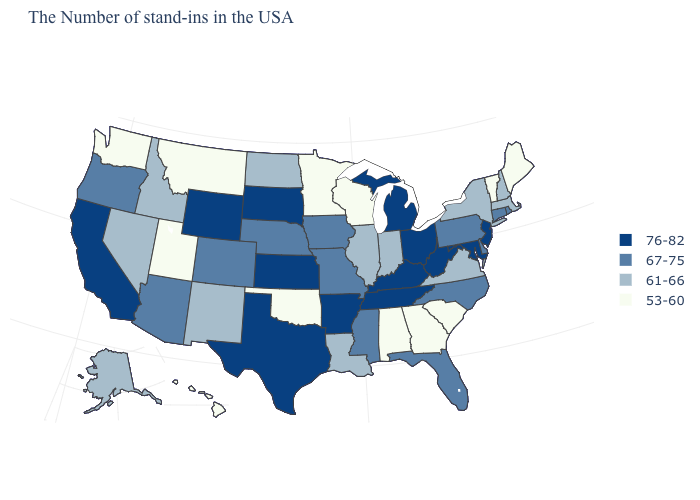Does Maine have the same value as Alabama?
Answer briefly. Yes. What is the value of Ohio?
Quick response, please. 76-82. Does Georgia have the same value as Oklahoma?
Write a very short answer. Yes. Which states hav the highest value in the Northeast?
Short answer required. New Jersey. Name the states that have a value in the range 61-66?
Be succinct. Massachusetts, New Hampshire, New York, Virginia, Indiana, Illinois, Louisiana, North Dakota, New Mexico, Idaho, Nevada, Alaska. What is the value of New Mexico?
Short answer required. 61-66. Name the states that have a value in the range 61-66?
Keep it brief. Massachusetts, New Hampshire, New York, Virginia, Indiana, Illinois, Louisiana, North Dakota, New Mexico, Idaho, Nevada, Alaska. What is the highest value in the West ?
Be succinct. 76-82. Which states have the lowest value in the West?
Concise answer only. Utah, Montana, Washington, Hawaii. Does the first symbol in the legend represent the smallest category?
Be succinct. No. Among the states that border New Hampshire , does Massachusetts have the lowest value?
Be succinct. No. Which states have the lowest value in the USA?
Short answer required. Maine, Vermont, South Carolina, Georgia, Alabama, Wisconsin, Minnesota, Oklahoma, Utah, Montana, Washington, Hawaii. Name the states that have a value in the range 67-75?
Answer briefly. Rhode Island, Connecticut, Delaware, Pennsylvania, North Carolina, Florida, Mississippi, Missouri, Iowa, Nebraska, Colorado, Arizona, Oregon. Which states have the lowest value in the USA?
Write a very short answer. Maine, Vermont, South Carolina, Georgia, Alabama, Wisconsin, Minnesota, Oklahoma, Utah, Montana, Washington, Hawaii. Does the first symbol in the legend represent the smallest category?
Be succinct. No. 